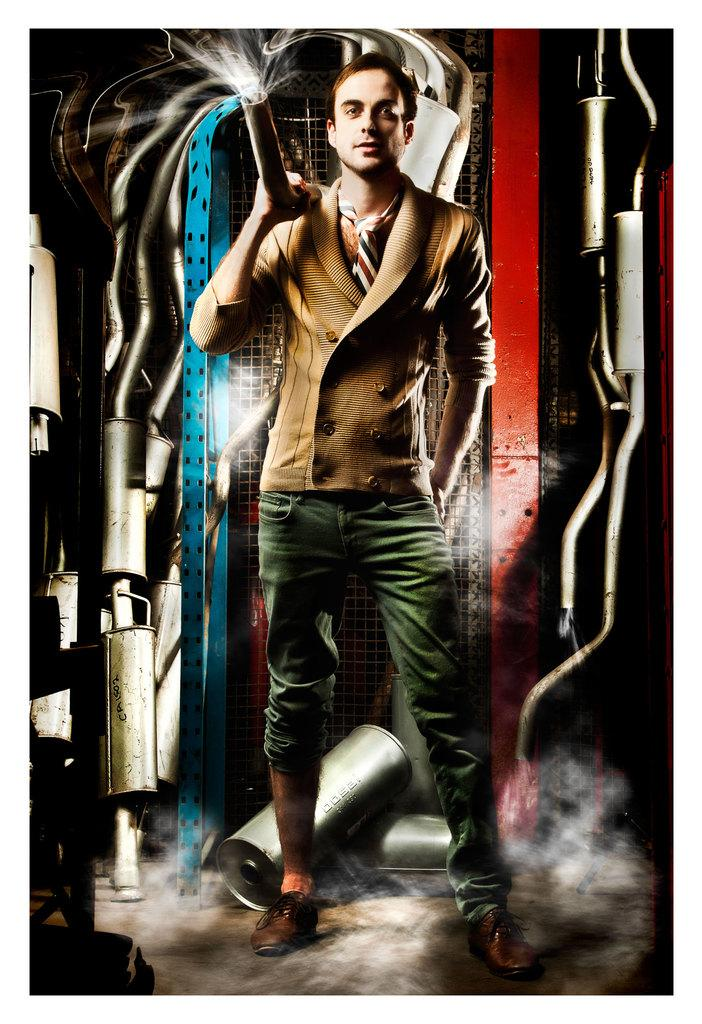What is the main subject of the image? There is a person standing in the image. Where is the person standing? The person is standing on the floor. What can be seen on the wall in the image? There is a wall with paints visible in the image. How does the actor adjust the light in the image? There is no actor or light present in the image; it features a person standing on the floor with a wall that has paints visible. 